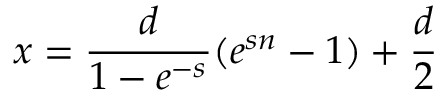Convert formula to latex. <formula><loc_0><loc_0><loc_500><loc_500>x = \frac { d } { 1 - e ^ { - s } } ( e ^ { s n } - 1 ) + \frac { d } { 2 }</formula> 